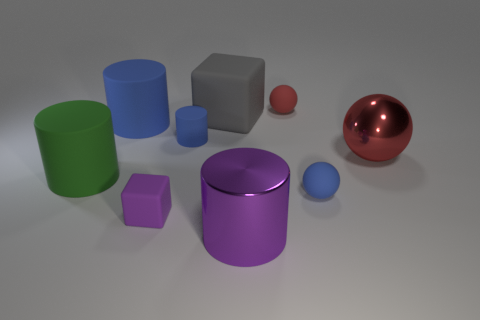Subtract all cubes. How many objects are left? 7 Add 5 red matte balls. How many red matte balls are left? 6 Add 9 large metal balls. How many large metal balls exist? 10 Subtract 0 cyan cubes. How many objects are left? 9 Subtract all matte things. Subtract all rubber spheres. How many objects are left? 0 